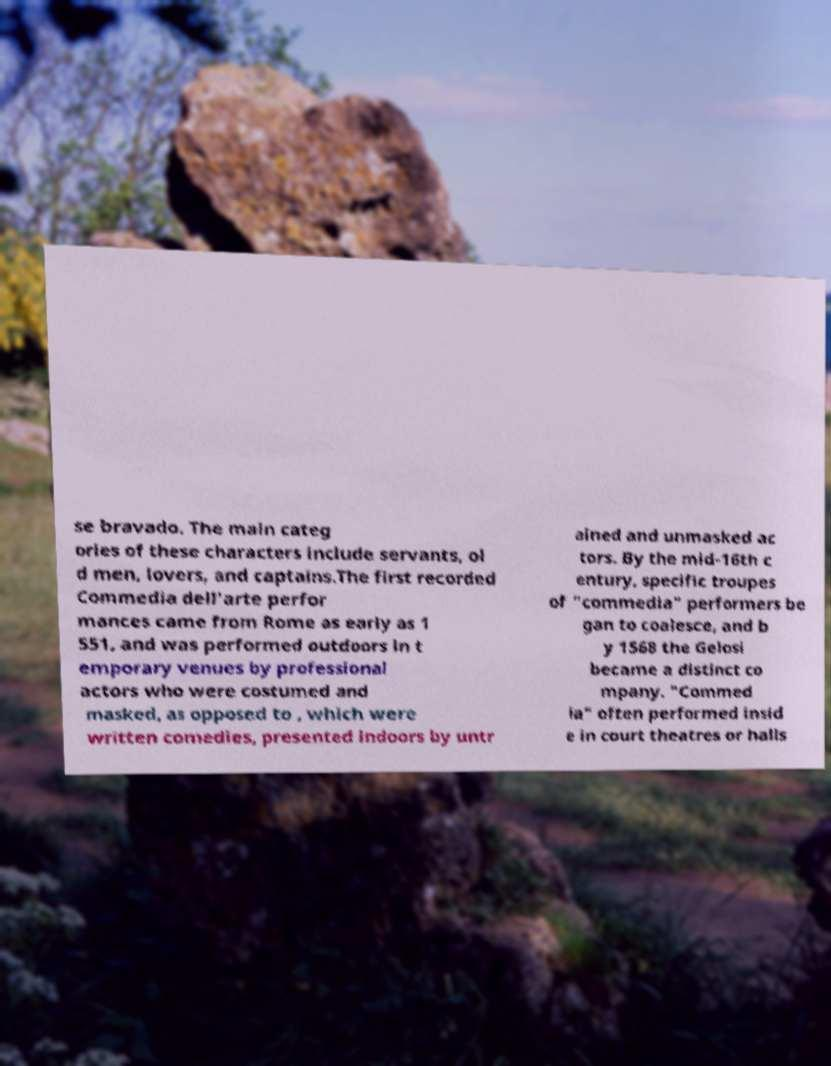For documentation purposes, I need the text within this image transcribed. Could you provide that? se bravado. The main categ ories of these characters include servants, ol d men, lovers, and captains.The first recorded Commedia dell'arte perfor mances came from Rome as early as 1 551, and was performed outdoors in t emporary venues by professional actors who were costumed and masked, as opposed to , which were written comedies, presented indoors by untr ained and unmasked ac tors. By the mid-16th c entury, specific troupes of "commedia" performers be gan to coalesce, and b y 1568 the Gelosi became a distinct co mpany. "Commed ia" often performed insid e in court theatres or halls 